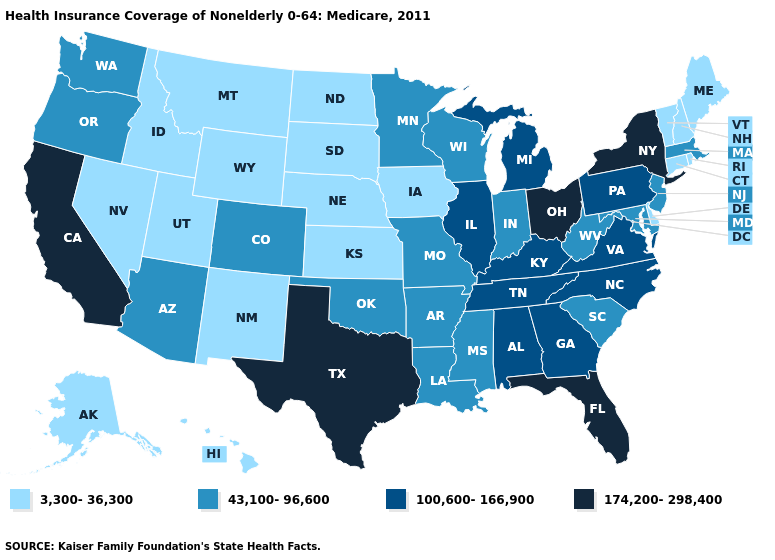What is the lowest value in states that border South Carolina?
Write a very short answer. 100,600-166,900. Does California have the highest value in the West?
Give a very brief answer. Yes. What is the value of New York?
Concise answer only. 174,200-298,400. Name the states that have a value in the range 43,100-96,600?
Answer briefly. Arizona, Arkansas, Colorado, Indiana, Louisiana, Maryland, Massachusetts, Minnesota, Mississippi, Missouri, New Jersey, Oklahoma, Oregon, South Carolina, Washington, West Virginia, Wisconsin. What is the value of Oregon?
Quick response, please. 43,100-96,600. Does Mississippi have a lower value than New York?
Be succinct. Yes. What is the value of Virginia?
Keep it brief. 100,600-166,900. Does Nevada have the same value as Massachusetts?
Write a very short answer. No. What is the highest value in states that border Alabama?
Short answer required. 174,200-298,400. Is the legend a continuous bar?
Keep it brief. No. Does Arizona have a higher value than Oklahoma?
Be succinct. No. What is the lowest value in the USA?
Be succinct. 3,300-36,300. What is the highest value in the USA?
Be succinct. 174,200-298,400. Which states have the lowest value in the Northeast?
Be succinct. Connecticut, Maine, New Hampshire, Rhode Island, Vermont. 